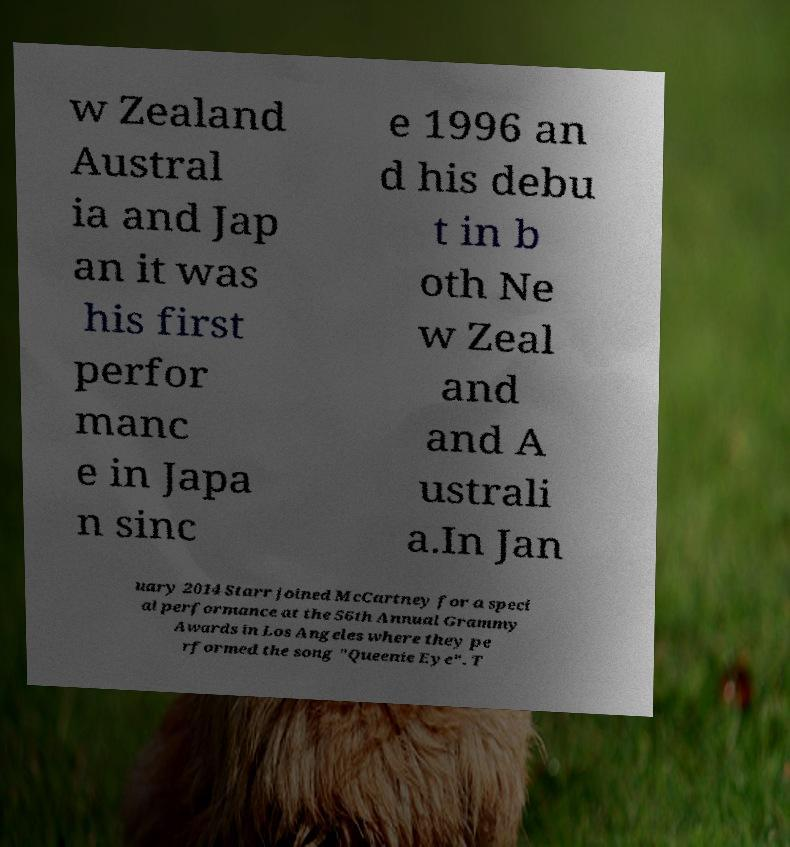What messages or text are displayed in this image? I need them in a readable, typed format. w Zealand Austral ia and Jap an it was his first perfor manc e in Japa n sinc e 1996 an d his debu t in b oth Ne w Zeal and and A ustrali a.In Jan uary 2014 Starr joined McCartney for a speci al performance at the 56th Annual Grammy Awards in Los Angeles where they pe rformed the song "Queenie Eye". T 